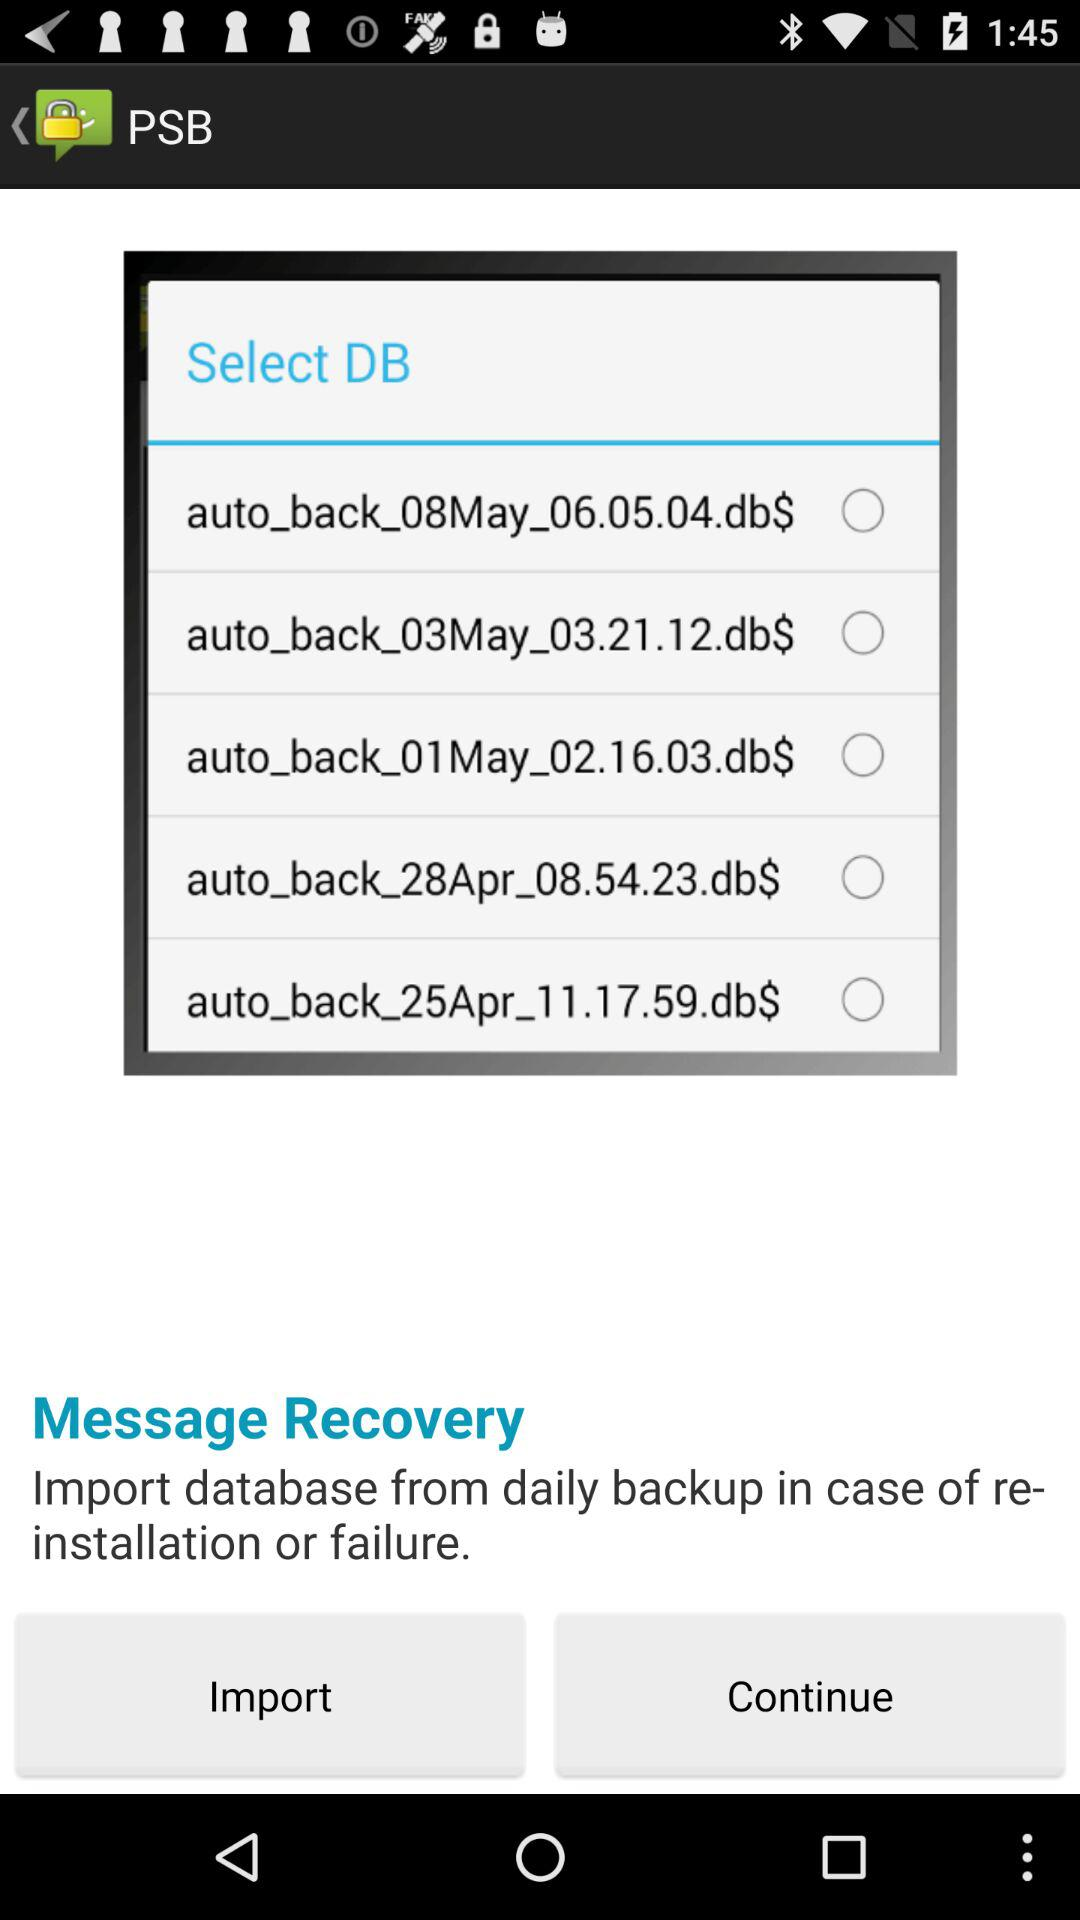How many days are represented by the available backup files?
Answer the question using a single word or phrase. 5 